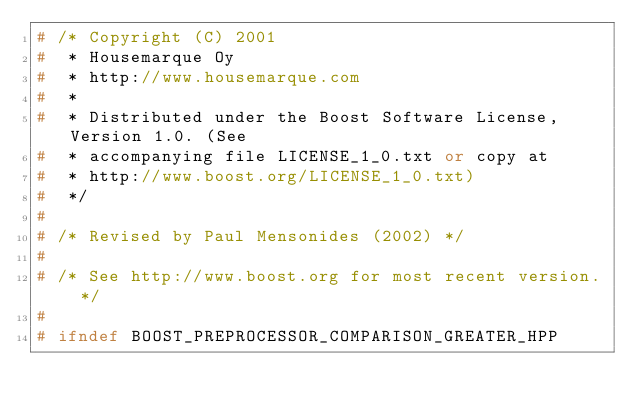<code> <loc_0><loc_0><loc_500><loc_500><_C++_># /* Copyright (C) 2001
#  * Housemarque Oy
#  * http://www.housemarque.com
#  *
#  * Distributed under the Boost Software License, Version 1.0. (See
#  * accompanying file LICENSE_1_0.txt or copy at
#  * http://www.boost.org/LICENSE_1_0.txt)
#  */
#
# /* Revised by Paul Mensonides (2002) */
#
# /* See http://www.boost.org for most recent version. */
#
# ifndef BOOST_PREPROCESSOR_COMPARISON_GREATER_HPP</code> 